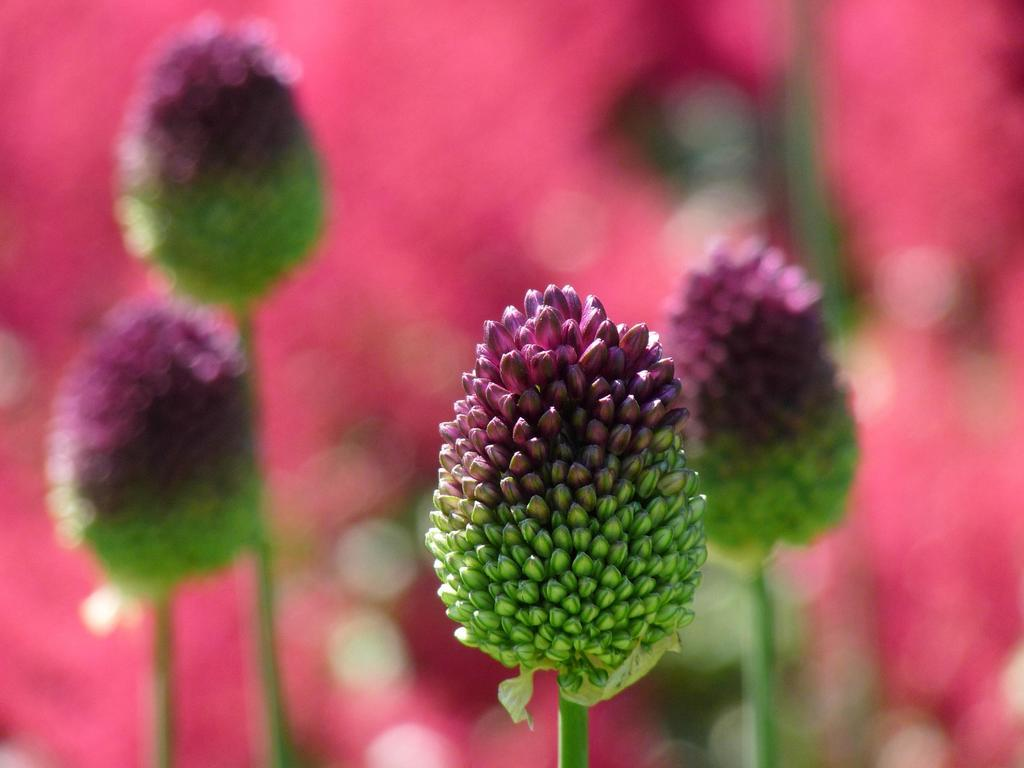What type of plant life is depicted in the image? There are buds with stems in the image. Can you describe the background of the image? The background of the image is blurry. What type of drawer can be seen in the image? There is no drawer present in the image; it features buds with stems against a blurry background. 